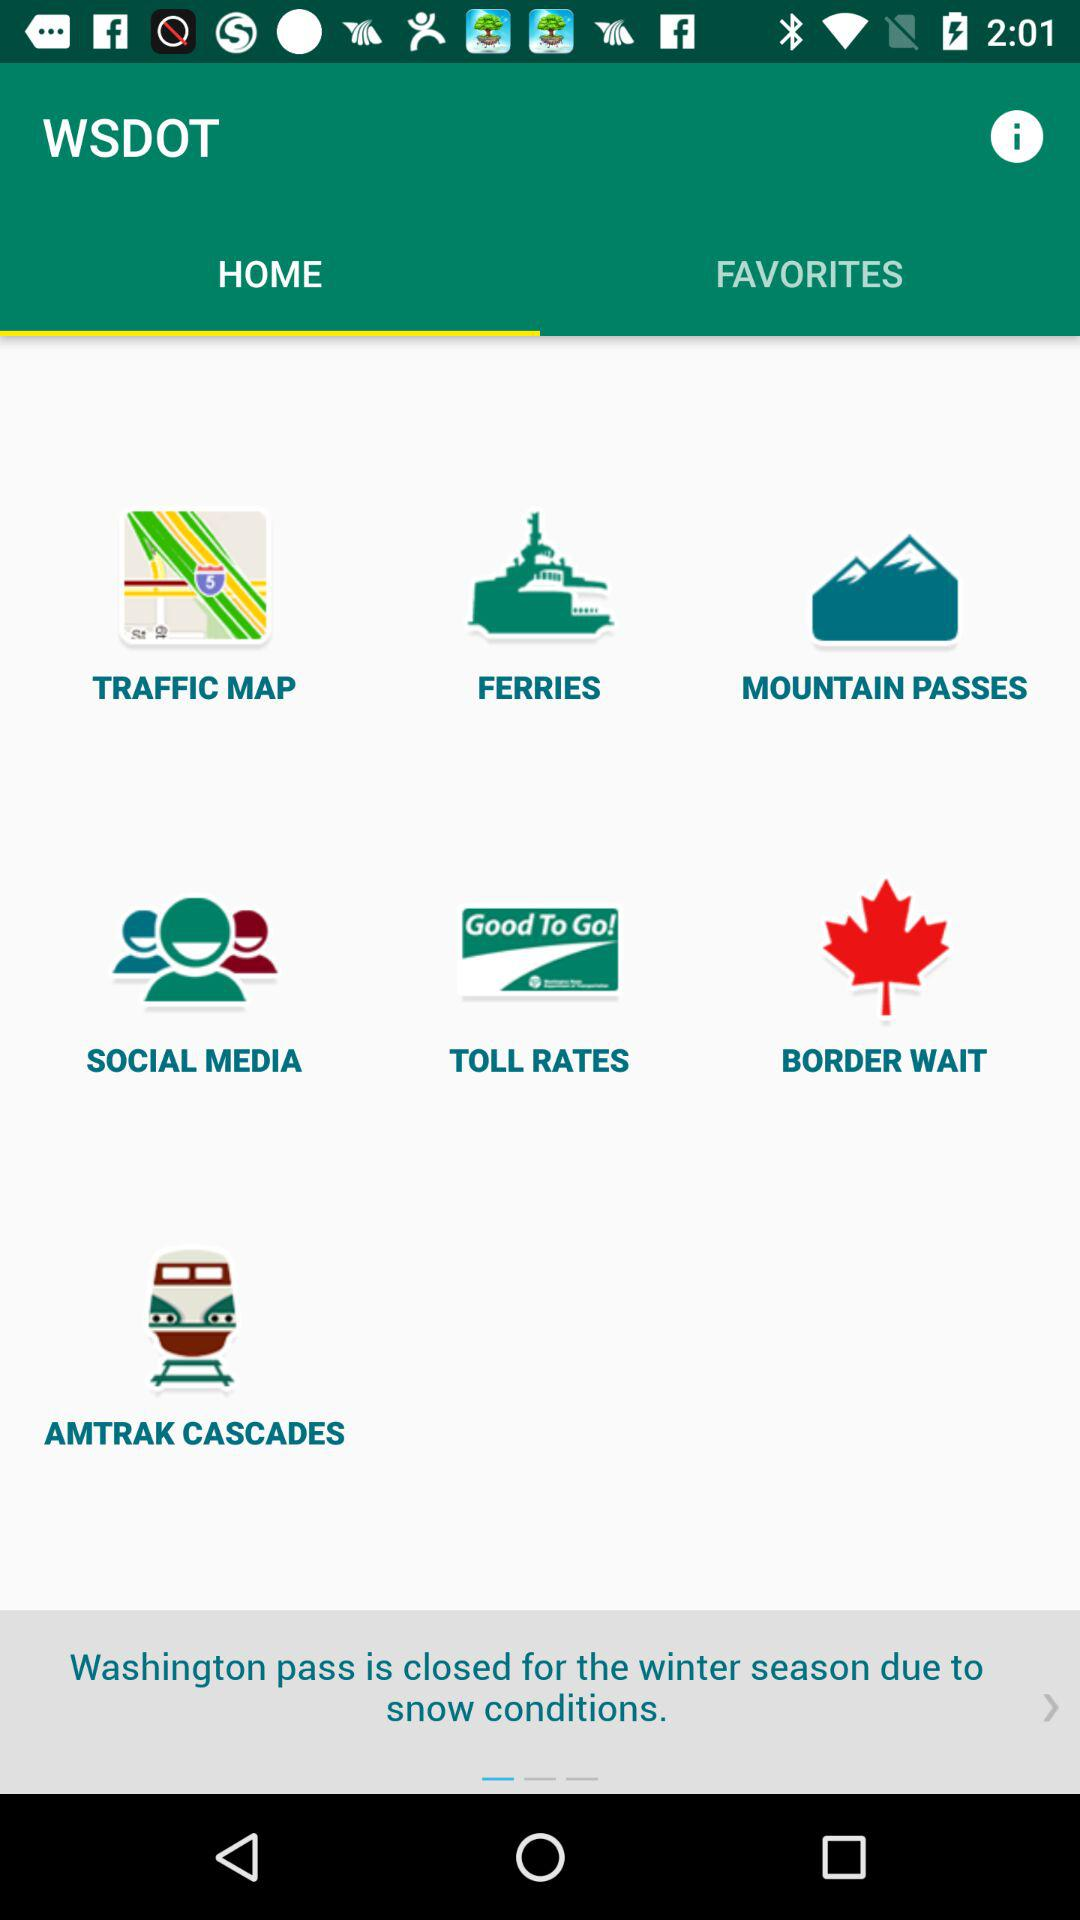What is the selected tab? The selected tab is "HOME". 